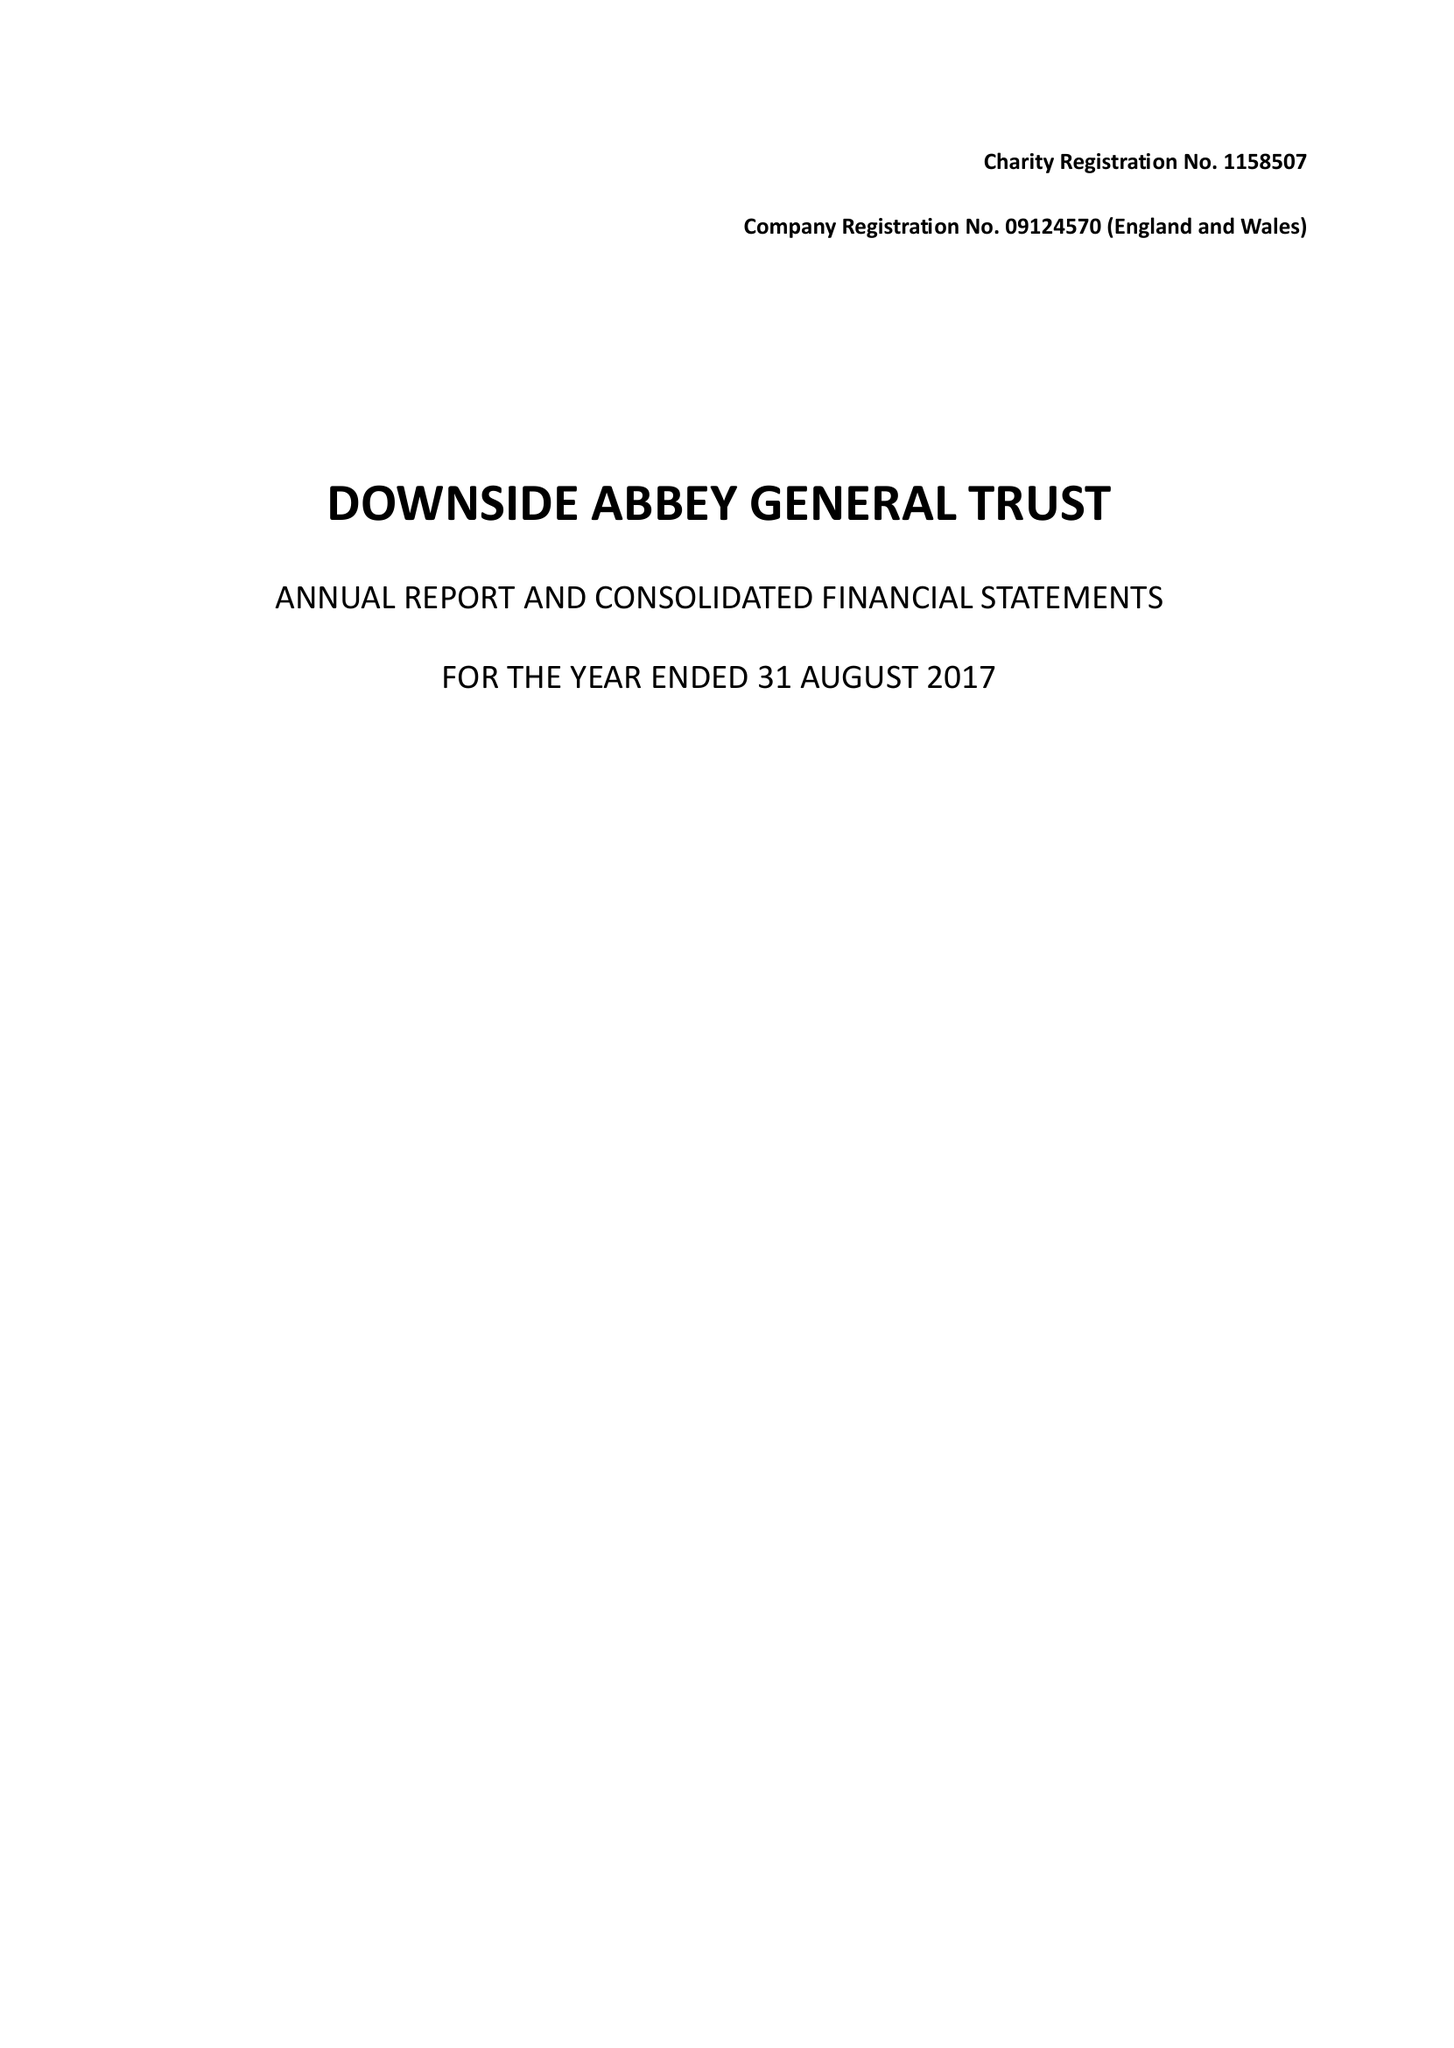What is the value for the address__street_line?
Answer the question using a single word or phrase. None 